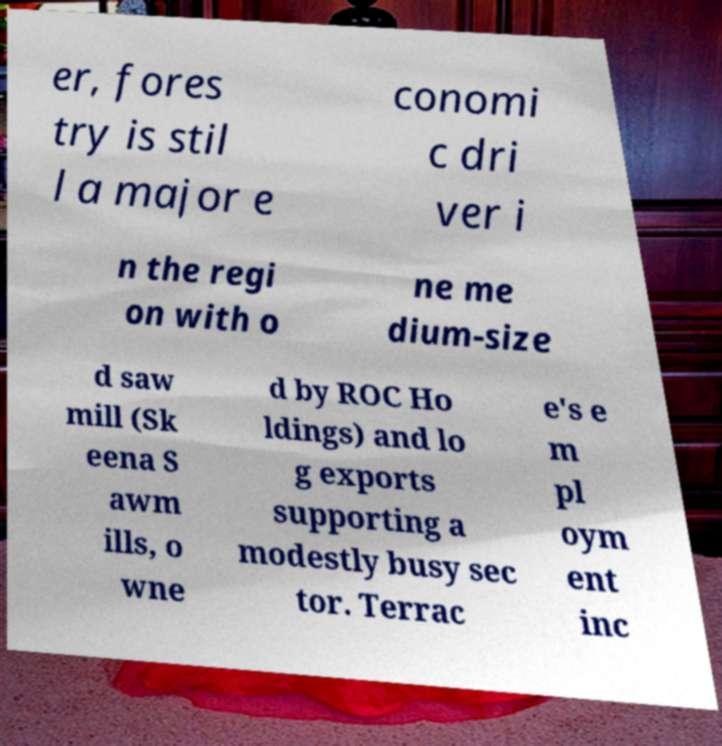Could you extract and type out the text from this image? er, fores try is stil l a major e conomi c dri ver i n the regi on with o ne me dium-size d saw mill (Sk eena S awm ills, o wne d by ROC Ho ldings) and lo g exports supporting a modestly busy sec tor. Terrac e's e m pl oym ent inc 